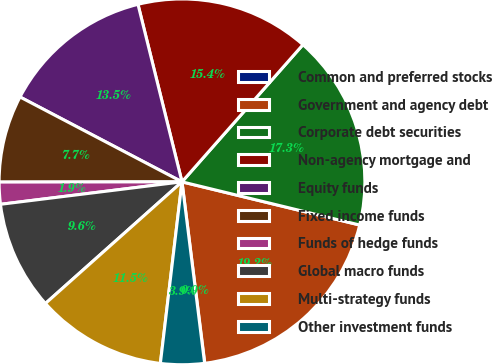Convert chart. <chart><loc_0><loc_0><loc_500><loc_500><pie_chart><fcel>Common and preferred stocks<fcel>Government and agency debt<fcel>Corporate debt securities<fcel>Non-agency mortgage and<fcel>Equity funds<fcel>Fixed income funds<fcel>Funds of hedge funds<fcel>Global macro funds<fcel>Multi-strategy funds<fcel>Other investment funds<nl><fcel>0.02%<fcel>19.21%<fcel>17.29%<fcel>15.37%<fcel>13.45%<fcel>7.7%<fcel>1.94%<fcel>9.62%<fcel>11.53%<fcel>3.86%<nl></chart> 